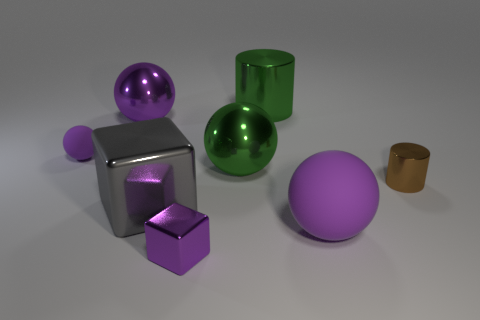What material is the tiny ball that is the same color as the large rubber object?
Your answer should be compact. Rubber. Is the color of the small shiny cube the same as the tiny matte thing?
Offer a very short reply. Yes. How many other things are there of the same material as the gray cube?
Your response must be concise. 5. The metal thing that is in front of the big purple thing that is in front of the small matte object is what shape?
Your answer should be compact. Cube. How big is the purple matte thing that is in front of the large gray thing?
Your answer should be compact. Large. Are the tiny brown thing and the tiny sphere made of the same material?
Give a very brief answer. No. What is the shape of the big green thing that is the same material as the large cylinder?
Your response must be concise. Sphere. Are there any other things of the same color as the big metallic cylinder?
Make the answer very short. Yes. What color is the large sphere that is on the right side of the green cylinder?
Offer a very short reply. Purple. There is a big metallic ball to the left of the tiny purple shiny block; is it the same color as the large rubber object?
Give a very brief answer. Yes. 